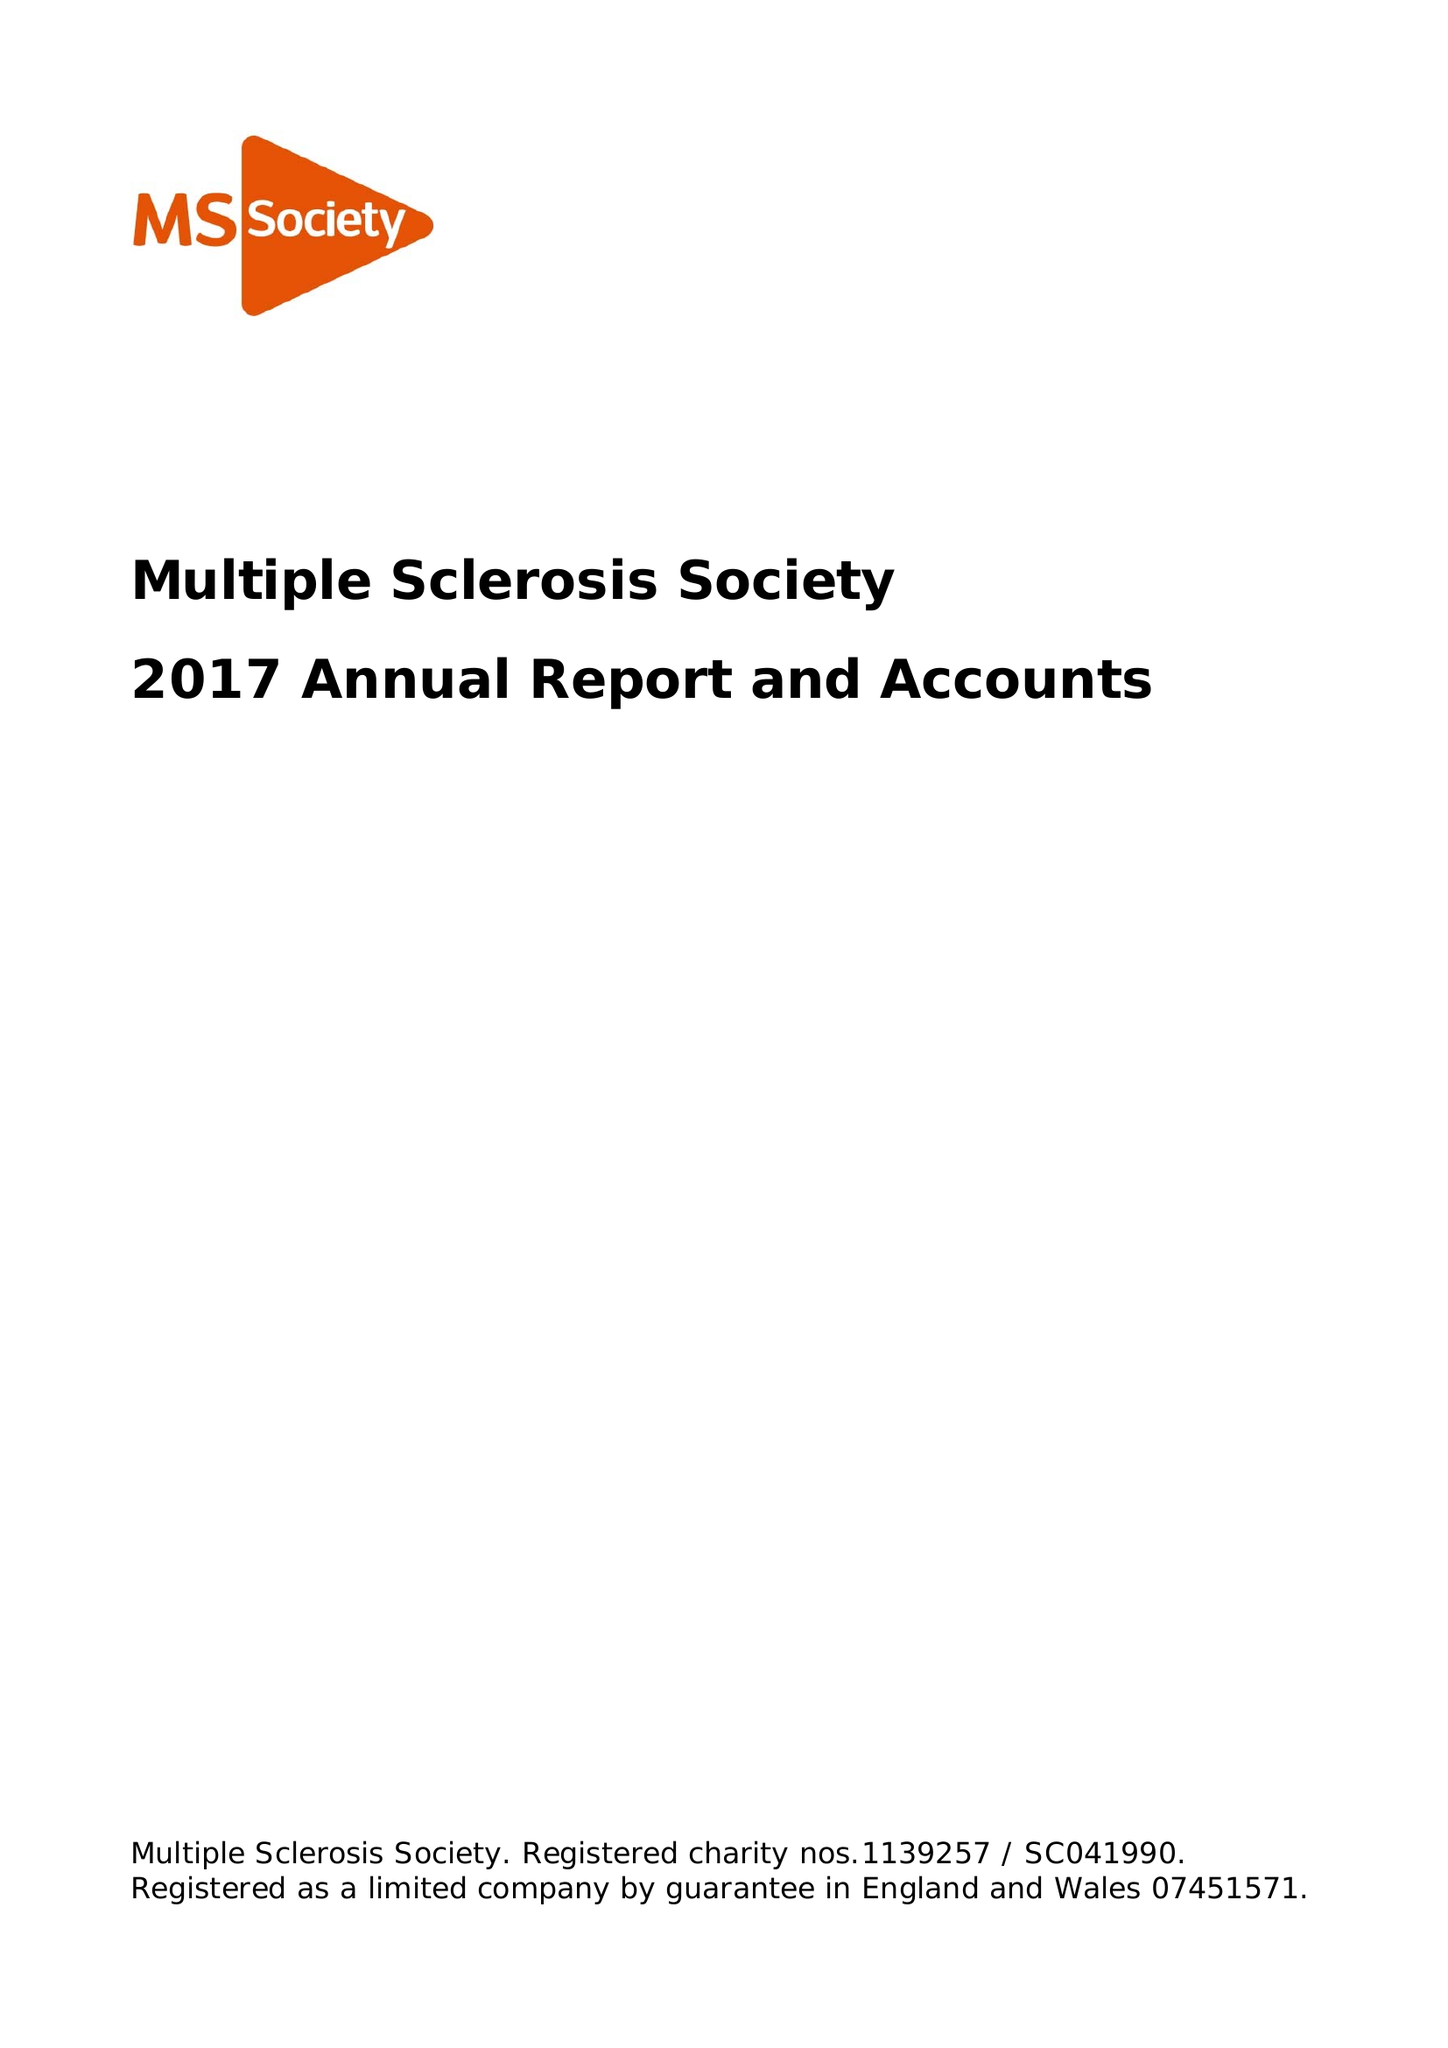What is the value for the address__postcode?
Answer the question using a single word or phrase. NW2 6ND 